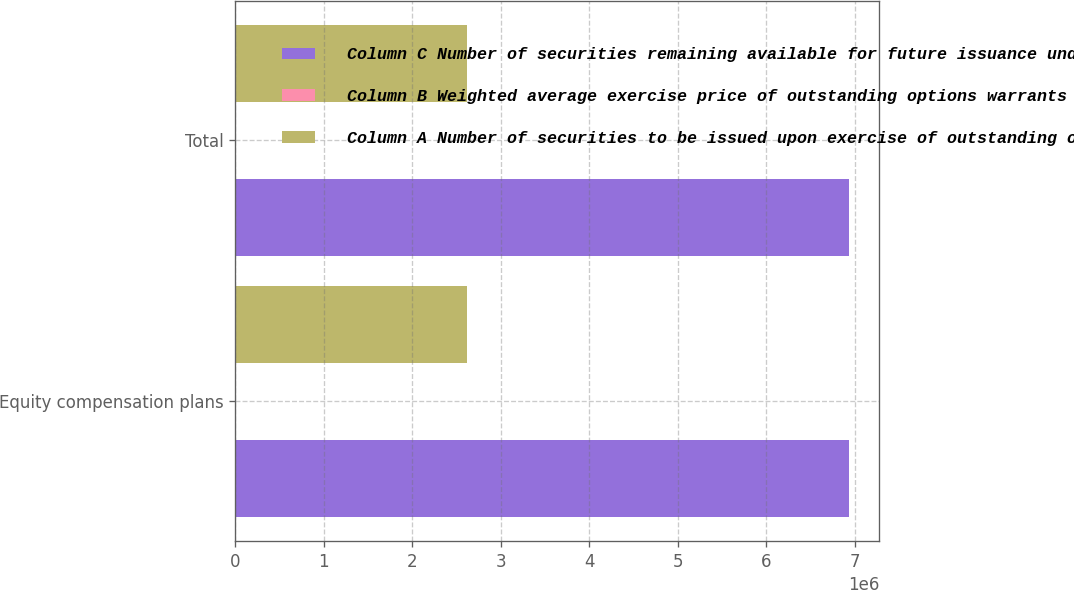<chart> <loc_0><loc_0><loc_500><loc_500><stacked_bar_chart><ecel><fcel>Equity compensation plans<fcel>Total<nl><fcel>Column C Number of securities remaining available for future issuance under equity compensation plans excluding securities reflected in Column A<fcel>6.93256e+06<fcel>6.93256e+06<nl><fcel>Column B Weighted average exercise price of outstanding options warrants and rights<fcel>35.45<fcel>35.45<nl><fcel>Column A Number of securities to be issued upon exercise of outstanding options warrants and rights<fcel>2.62225e+06<fcel>2.62225e+06<nl></chart> 